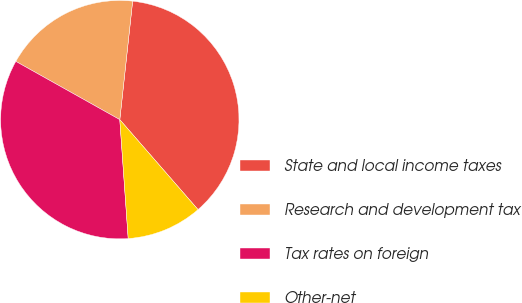Convert chart to OTSL. <chart><loc_0><loc_0><loc_500><loc_500><pie_chart><fcel>State and local income taxes<fcel>Research and development tax<fcel>Tax rates on foreign<fcel>Other-net<nl><fcel>36.89%<fcel>18.59%<fcel>34.25%<fcel>10.27%<nl></chart> 